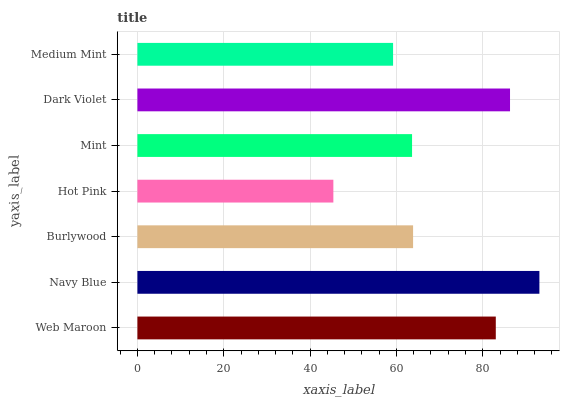Is Hot Pink the minimum?
Answer yes or no. Yes. Is Navy Blue the maximum?
Answer yes or no. Yes. Is Burlywood the minimum?
Answer yes or no. No. Is Burlywood the maximum?
Answer yes or no. No. Is Navy Blue greater than Burlywood?
Answer yes or no. Yes. Is Burlywood less than Navy Blue?
Answer yes or no. Yes. Is Burlywood greater than Navy Blue?
Answer yes or no. No. Is Navy Blue less than Burlywood?
Answer yes or no. No. Is Burlywood the high median?
Answer yes or no. Yes. Is Burlywood the low median?
Answer yes or no. Yes. Is Hot Pink the high median?
Answer yes or no. No. Is Hot Pink the low median?
Answer yes or no. No. 